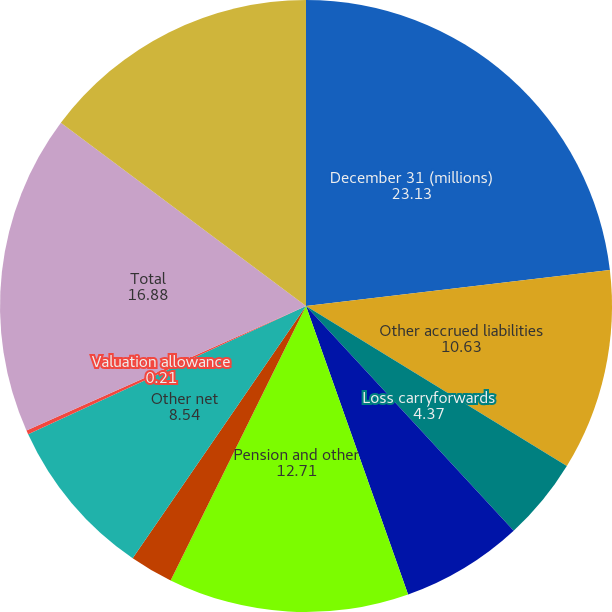Convert chart to OTSL. <chart><loc_0><loc_0><loc_500><loc_500><pie_chart><fcel>December 31 (millions)<fcel>Other accrued liabilities<fcel>Loss carryforwards<fcel>Share-based compensation<fcel>Pension and other<fcel>Foreign tax credits<fcel>Other net<fcel>Valuation allowance<fcel>Total<fcel>Property plant and equipment<nl><fcel>23.13%<fcel>10.63%<fcel>4.37%<fcel>6.46%<fcel>12.71%<fcel>2.29%<fcel>8.54%<fcel>0.21%<fcel>16.88%<fcel>14.79%<nl></chart> 